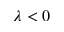Convert formula to latex. <formula><loc_0><loc_0><loc_500><loc_500>\lambda < 0</formula> 